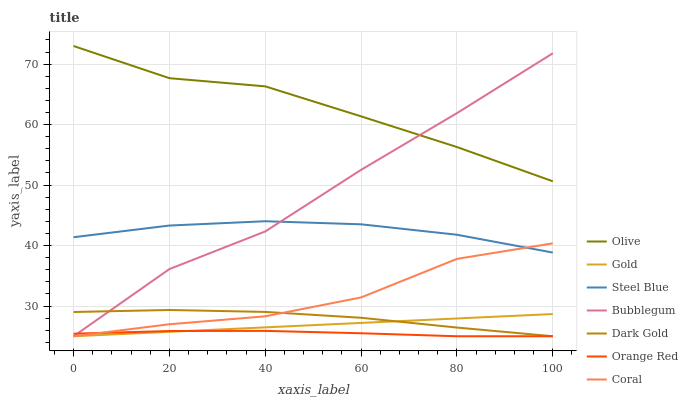Does Orange Red have the minimum area under the curve?
Answer yes or no. Yes. Does Olive have the maximum area under the curve?
Answer yes or no. Yes. Does Dark Gold have the minimum area under the curve?
Answer yes or no. No. Does Dark Gold have the maximum area under the curve?
Answer yes or no. No. Is Gold the smoothest?
Answer yes or no. Yes. Is Bubblegum the roughest?
Answer yes or no. Yes. Is Dark Gold the smoothest?
Answer yes or no. No. Is Dark Gold the roughest?
Answer yes or no. No. Does Steel Blue have the lowest value?
Answer yes or no. No. Does Olive have the highest value?
Answer yes or no. Yes. Does Dark Gold have the highest value?
Answer yes or no. No. Is Gold less than Olive?
Answer yes or no. Yes. Is Olive greater than Dark Gold?
Answer yes or no. Yes. Does Steel Blue intersect Coral?
Answer yes or no. Yes. Is Steel Blue less than Coral?
Answer yes or no. No. Is Steel Blue greater than Coral?
Answer yes or no. No. Does Gold intersect Olive?
Answer yes or no. No. 